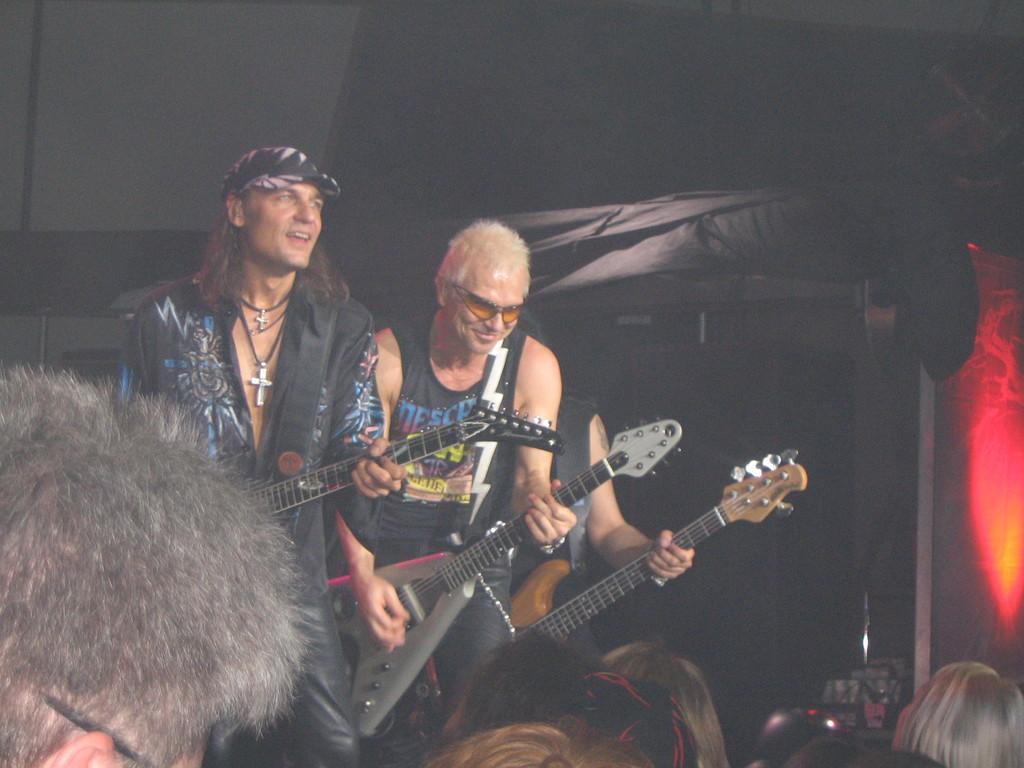Please provide a concise description of this image. The people wearing black dress is playing guitar and there are group of people in front of them. 